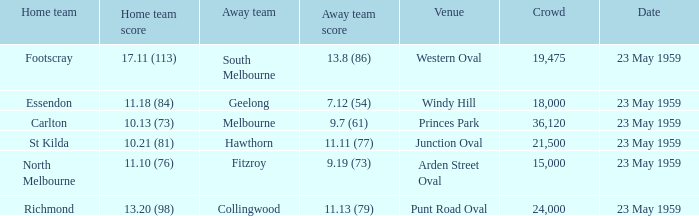What was the score of the home team during the match at punt road oval? 13.20 (98). 